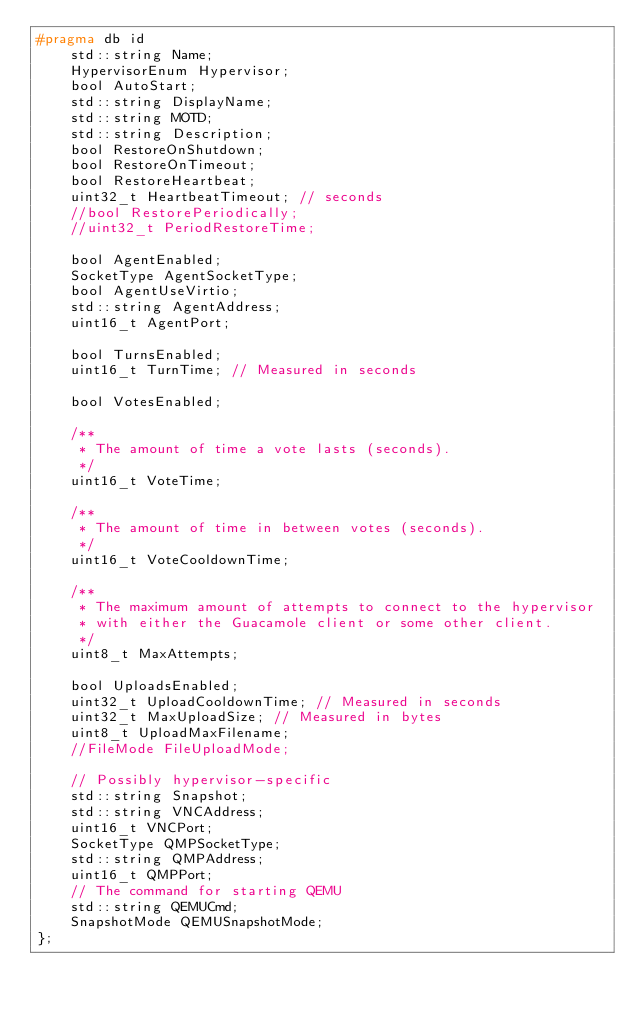<code> <loc_0><loc_0><loc_500><loc_500><_C_>#pragma db id
	std::string Name;
	HypervisorEnum Hypervisor;
	bool AutoStart;
	std::string DisplayName;
	std::string MOTD;
	std::string Description;
	bool RestoreOnShutdown;
	bool RestoreOnTimeout;
	bool RestoreHeartbeat;
	uint32_t HeartbeatTimeout; // seconds
	//bool RestorePeriodically;
	//uint32_t PeriodRestoreTime;

	bool AgentEnabled;
	SocketType AgentSocketType;
	bool AgentUseVirtio;
	std::string AgentAddress;
	uint16_t AgentPort;

	bool TurnsEnabled;
	uint16_t TurnTime; // Measured in seconds

	bool VotesEnabled;

	/**
	 * The amount of time a vote lasts (seconds).
	 */
	uint16_t VoteTime;

	/**
	 * The amount of time in between votes (seconds).
	 */
	uint16_t VoteCooldownTime;

	/**
	 * The maximum amount of attempts to connect to the hypervisor
	 * with either the Guacamole client or some other client.
	 */
	uint8_t MaxAttempts;

	bool UploadsEnabled;
	uint32_t UploadCooldownTime; // Measured in seconds
	uint32_t MaxUploadSize; // Measured in bytes
	uint8_t UploadMaxFilename;
	//FileMode FileUploadMode;

	// Possibly hypervisor-specific
	std::string Snapshot;
	std::string VNCAddress;
	uint16_t VNCPort;
	SocketType QMPSocketType;
	std::string QMPAddress;
	uint16_t QMPPort;
	// The command for starting QEMU 
	std::string QEMUCmd;
	SnapshotMode QEMUSnapshotMode;
};
</code> 